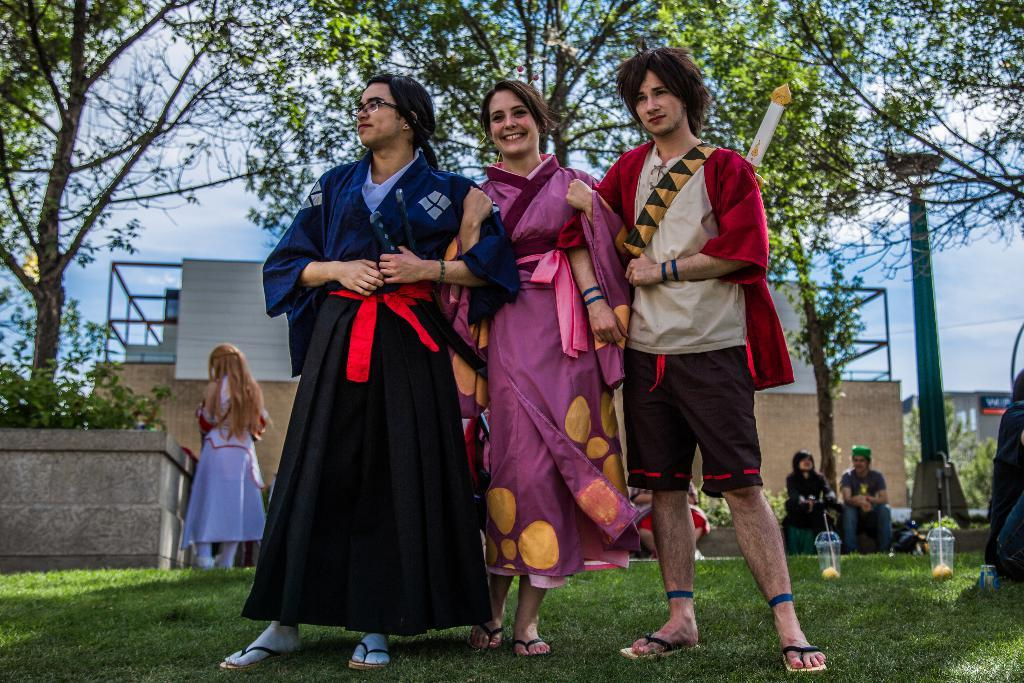What is the appearance of the woman in the image? There is a beautiful woman in the image. What is the woman doing in the image? The woman is standing and smiling. Where is the man positioned in relation to the woman? The man is standing on the right side of the woman. What can be seen in the background of the image? There are people, a building, and green trees visible in the background. What type of comfort can be seen in the image? There is no specific comfort visible in the image; it features a woman standing and smiling, a man standing on her right side, and a background with people, a building, and green trees. What nerve is being stimulated by the balloon in the image? There is no balloon present in the image, so it is not possible to determine which nerve might be stimulated. 